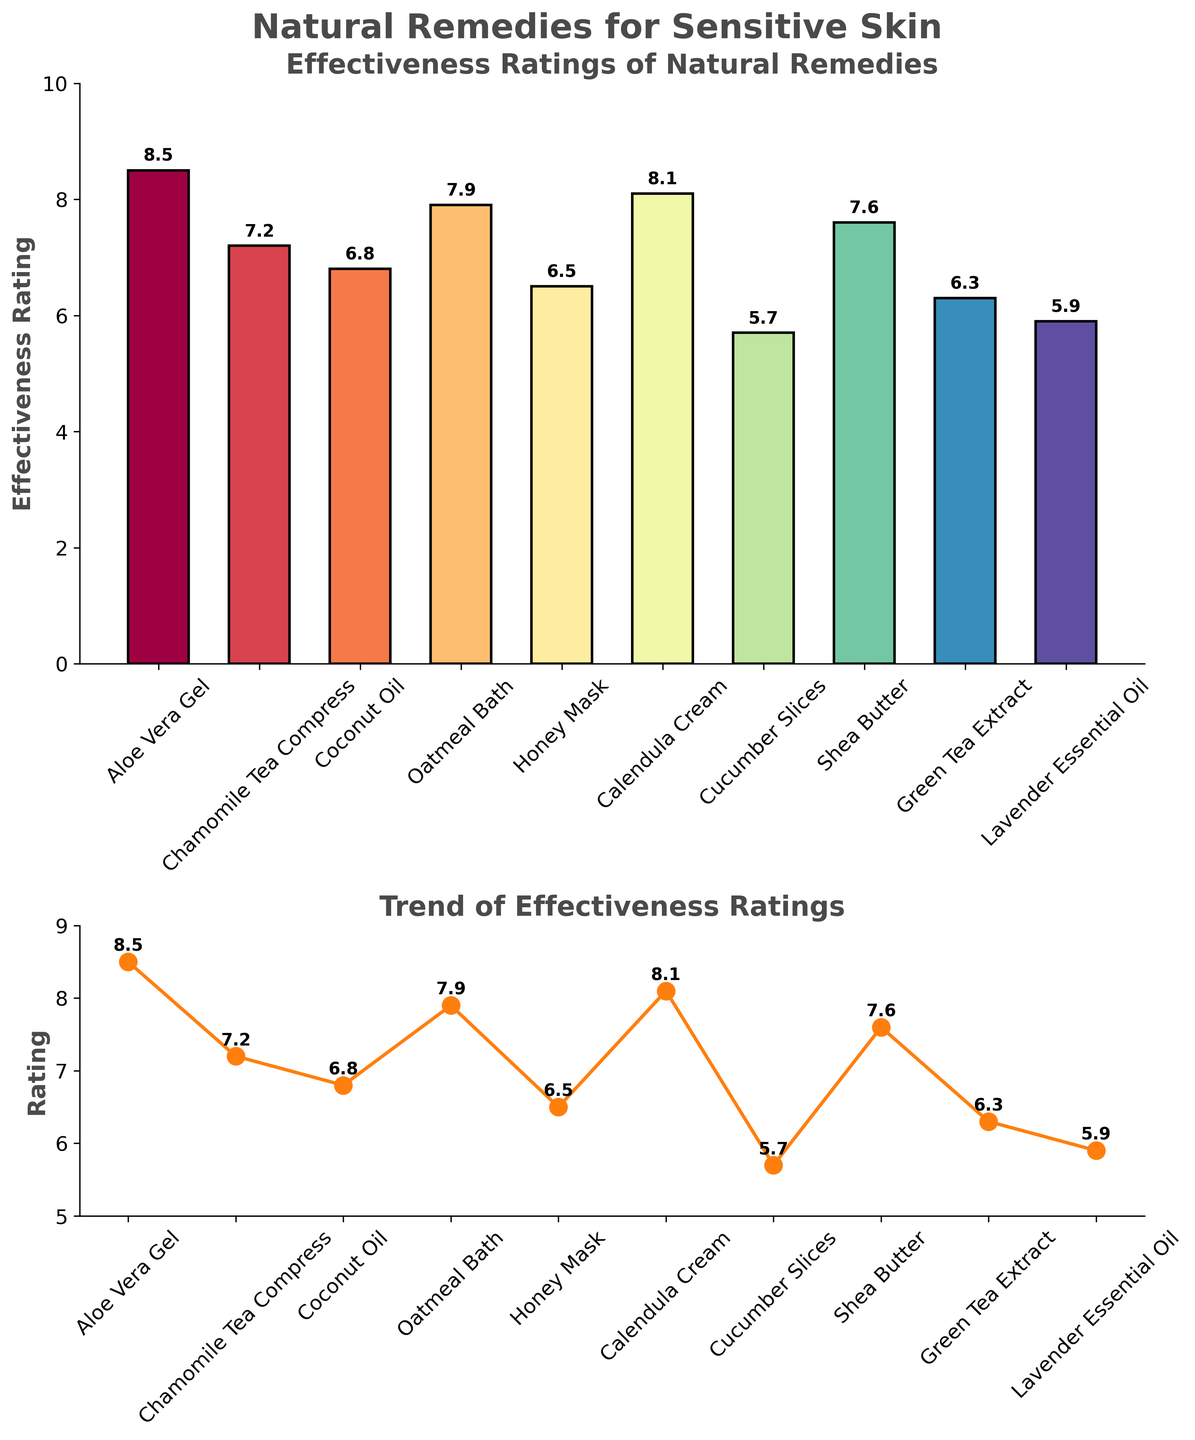What is the effectiveness rating of Aloe Vera Gel? The bar plot shows the effectiveness ratings of various natural remedies, and Aloe Vera Gel is listed first. The height of its bar is labeled with the value 8.5.
Answer: 8.5 Which remedy has the lowest effectiveness rating? The lowest effectiveness rating can be identified by finding the shortest bar in the bar plot and cross-referencing it with the label. Cucumber Slices have the shortest bar, which indicates a rating of 5.7.
Answer: Cucumber Slices What is the average effectiveness rating of all remedies? To calculate the average, sum all the effectiveness ratings and then divide by the number of ratings. The ratings are 8.5, 7.2, 6.8, 7.9, 6.5, 8.1, 5.7, 7.6, 6.3, 5.9. The sum is 68.5, and there are 10 remedies, so the average is 68.5 / 10.
Answer: 6.85 Which remedy has a higher effectiveness rating, Honey Mask or Lavender Essential Oil? Compare the heights of the bars for Honey Mask and Lavender Essential Oil. Honey Mask has an effectiveness rating of 6.5, whereas Lavender Essential Oil has a rating of 5.9.
Answer: Honey Mask Which remedy comes third in the trend of effectiveness ratings in the horizontal line plot? Count the points in the horizontal line plot from left to right. The third remedy is Coconut Oil with a rating of 6.8.
Answer: Coconut Oil How many remedies have an effectiveness rating above 7? Count the number of bars with heights indicating ratings above 7 in the bar plot. Aloe Vera Gel (8.5), Chamomile Tea Compress (7.2), Oatmeal Bath (7.9), Calendula Cream (8.1), and Shea Butter (7.6).
Answer: 5 What is the combined effectiveness rating of Chamomile Tea Compress and Oatmeal Bath? Add the effectiveness ratings of Chamomile Tea Compress (7.2) and Oatmeal Bath (7.9).
Answer: 15.1 Which remedy has the closest effectiveness rating to the average effectiveness rating of all remedies? The average effectiveness rating is 6.85. The remedy closest to this average is Coconut Oil with a rating of 6.8.
Answer: Coconut Oil What is the difference in effectiveness ratings between the highest and lowest remedies? Identify the highest rating (Aloe Vera Gel, 8.5) and the lowest rating (Cucumber Slices, 5.7), then find the difference between these ratings.
Answer: 2.8 Which remedy showed a notable peak in effectiveness rating in the trend plot? Look at the horizontal line plot for any visible peaks in ratings. Aloe Vera Gel shows a notable peak with a rating of 8.5.
Answer: Aloe Vera Gel 